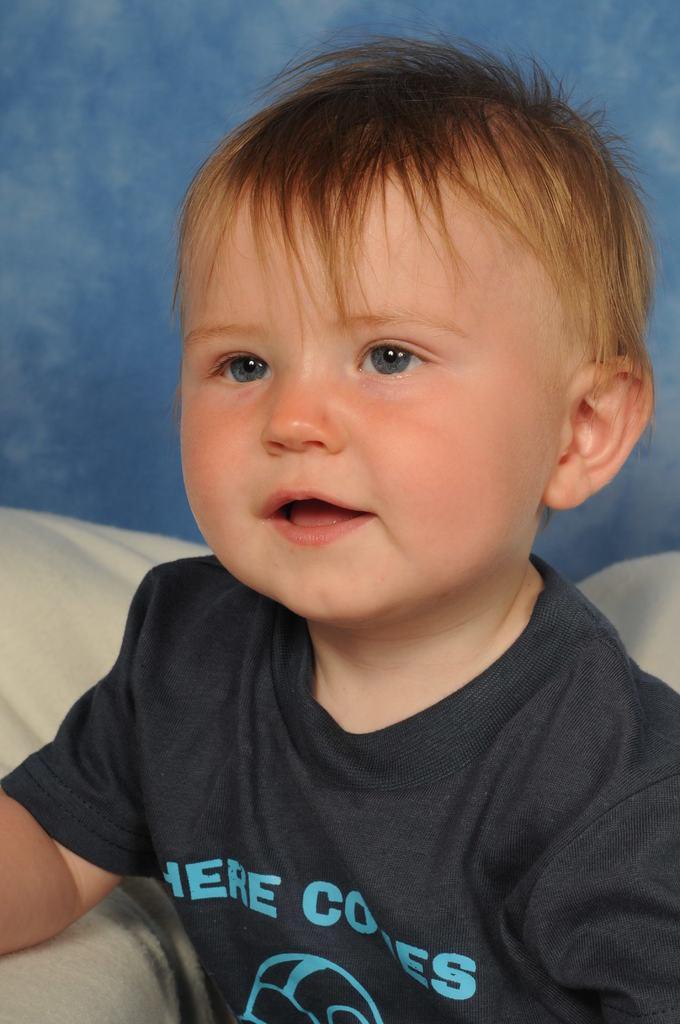Could you give a brief overview of what you see in this image? This image consists of a kid is sitting on a sofa and a wall. This image is taken may be in a room. 